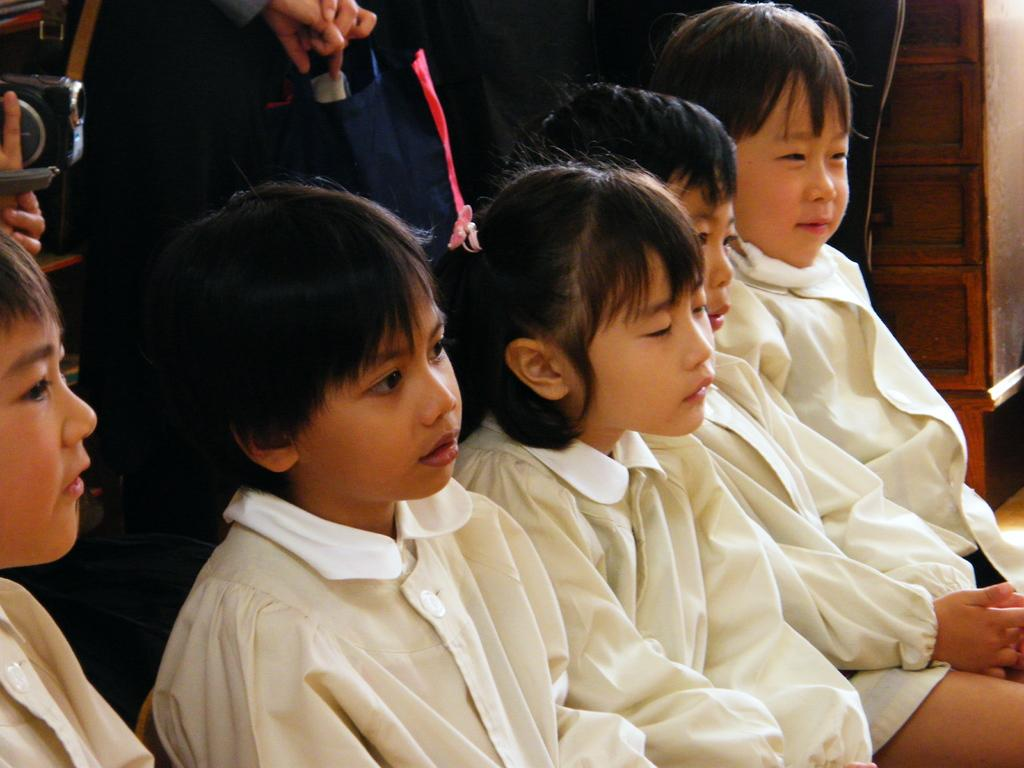What is happening in the foreground of the picture? There are boys and a girl in the foreground of the picture. What are the children wearing? The children are wearing white dresses. What can be seen in the background of the picture? In the background, there is a person holding a camera and another person standing. How many pages are visible in the picture? There are no pages present in the picture. What type of taste can be experienced from the children's dresses in the picture? The children's dresses are not edible, so there is no taste associated with them. 